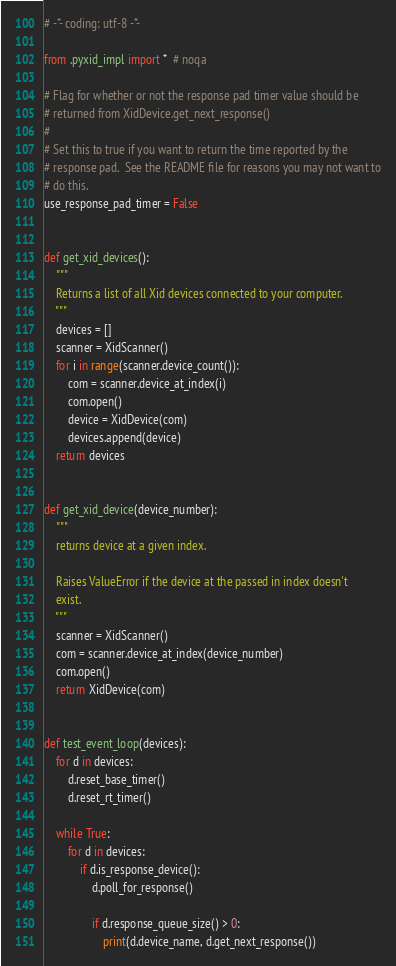<code> <loc_0><loc_0><loc_500><loc_500><_Python_># -*- coding: utf-8 -*-

from .pyxid_impl import *  # noqa

# Flag for whether or not the response pad timer value should be
# returned from XidDevice.get_next_response()
#
# Set this to true if you want to return the time reported by the
# response pad.  See the README file for reasons you may not want to
# do this.
use_response_pad_timer = False


def get_xid_devices():
    """
    Returns a list of all Xid devices connected to your computer.
    """
    devices = []
    scanner = XidScanner()
    for i in range(scanner.device_count()):
        com = scanner.device_at_index(i)
        com.open()
        device = XidDevice(com)
        devices.append(device)
    return devices


def get_xid_device(device_number):
    """
    returns device at a given index.

    Raises ValueError if the device at the passed in index doesn't
    exist.
    """
    scanner = XidScanner()
    com = scanner.device_at_index(device_number)
    com.open()
    return XidDevice(com)


def test_event_loop(devices):
    for d in devices:
        d.reset_base_timer()
        d.reset_rt_timer()

    while True:
        for d in devices:
            if d.is_response_device():
                d.poll_for_response()

                if d.response_queue_size() > 0:
                    print(d.device_name, d.get_next_response())
</code> 